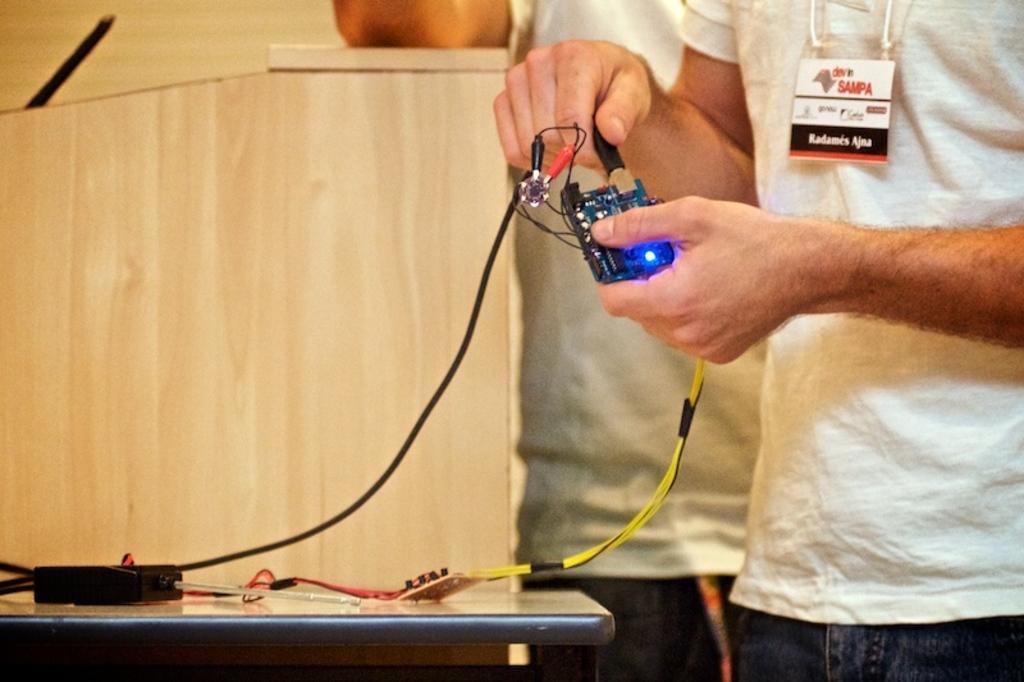Can you describe this image briefly? In this image in front there is a person holding some object. Beside him there is another person. In front of them there is a table. On top of it there is a cable. In the background of the image there is a wall. 